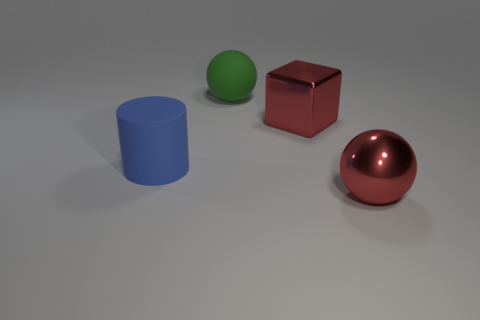Can you describe the lighting in the scene? The lighting in the scene is soft and diffused, creating gentle shadows on the ground. The source of the light appears to be above and slightly in front of the objects, casting subtle highlights and soft shading that enhance the objects' three-dimensional forms. How does the lighting affect the mood of the image? The soft, diffused lighting creates a calm and serene mood. It results in a clean and minimalistic aesthetic, which draws attention to the objects' shapes and the interplay of light and shadow, giving the scene a contemplative quality. 